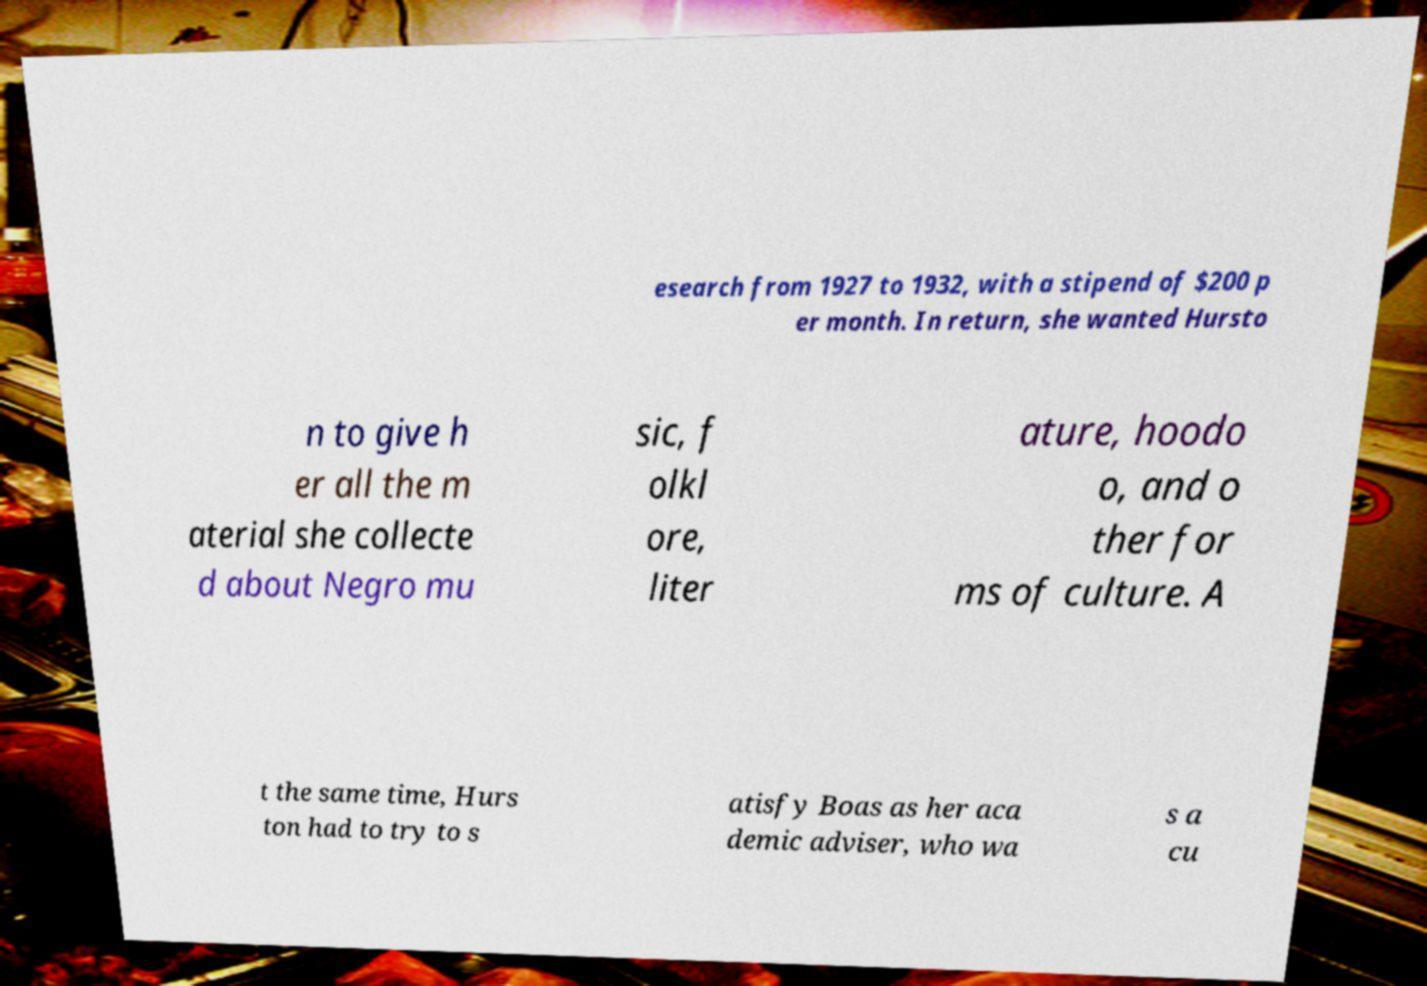I need the written content from this picture converted into text. Can you do that? esearch from 1927 to 1932, with a stipend of $200 p er month. In return, she wanted Hursto n to give h er all the m aterial she collecte d about Negro mu sic, f olkl ore, liter ature, hoodo o, and o ther for ms of culture. A t the same time, Hurs ton had to try to s atisfy Boas as her aca demic adviser, who wa s a cu 